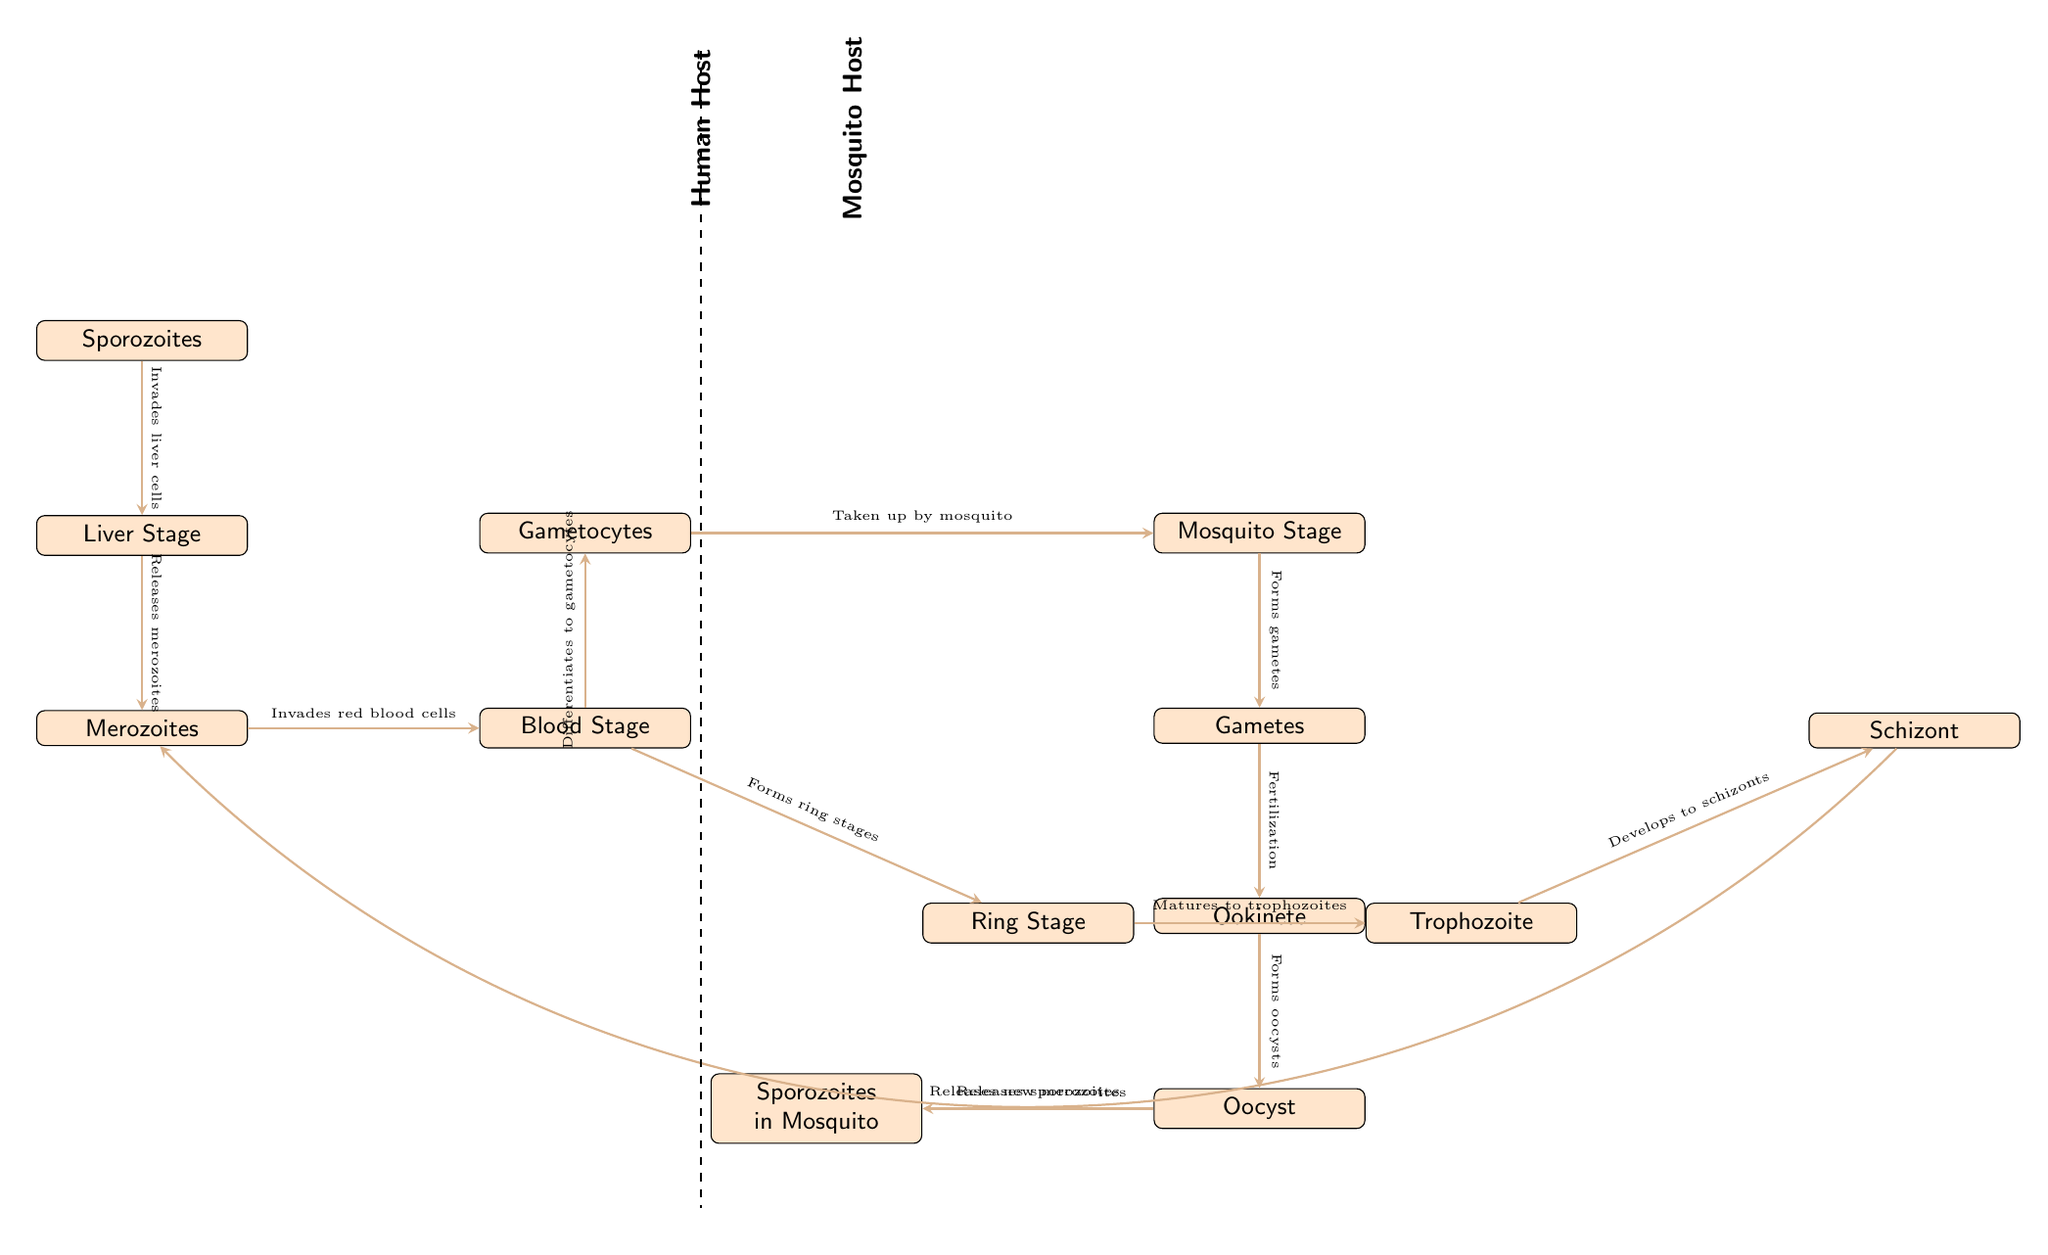What is the first stage of the malaria lifecycle in humans? The diagram shows that the first stage in the human host is "Sporozoites", which are introduced into the bloodstream through a mosquito bite.
Answer: Sporozoites How many stages are shown in the mosquito lifecycle? The diagram lists four stages in the mosquito lifecycle: "Gametes", "Ookinete", "Oocyst", and "Sporozoites in Mosquito". Counting these nodes gives us a total of four stages.
Answer: 4 What do merozoites invade in the human host? The diagram indicates that merozoites invade "red blood cells", which is stated at the edge connecting the "merozoites" node to the "blood stage" node.
Answer: Red blood cells What happens after the gametocytes are taken up by the mosquito? The diagram indicates that once the gametocytes are taken up by the mosquito, they enter the "Mosquito Stage", which leads to the formation of "Gametes". This indicates a progression from one mode of reproduction in humans to the gametogenesis process in the mosquito.
Answer: Forms gametes What mature stage comes after the ring stage in the blood stage of the human lifecycle? According to the diagram, after the "Ring Stage", the next mature stage is the "Trophozoite", marking one of the stages of malaria infection in red blood cells.
Answer: Trophozoite Which stage directly releases new merozoites? The diagram shows that "Schizont" releases new merozoites, indicating its role in the lifecycle of malaria in the human host. This can be found by tracing the edge from the "Schizont" node to the "Merozoites" node.
Answer: Schizont How many edges connect the blood stage to the gametocyte and ring stage? The blood stage connects to the ring stage with one edge (which describes the maturation process) and to the gametocyte with another edge. Thus, there are a total of two edges connecting to the blood stage.
Answer: 2 What stage of the lifecycle represents the sporozoites being released from the oocyst? The diagram illustrates that "Sporozoites in Mosquito" represents the stage where sporozoites are released from the oocyst, following the development of the oocyst after fertilization.
Answer: Sporozoites in Mosquito 